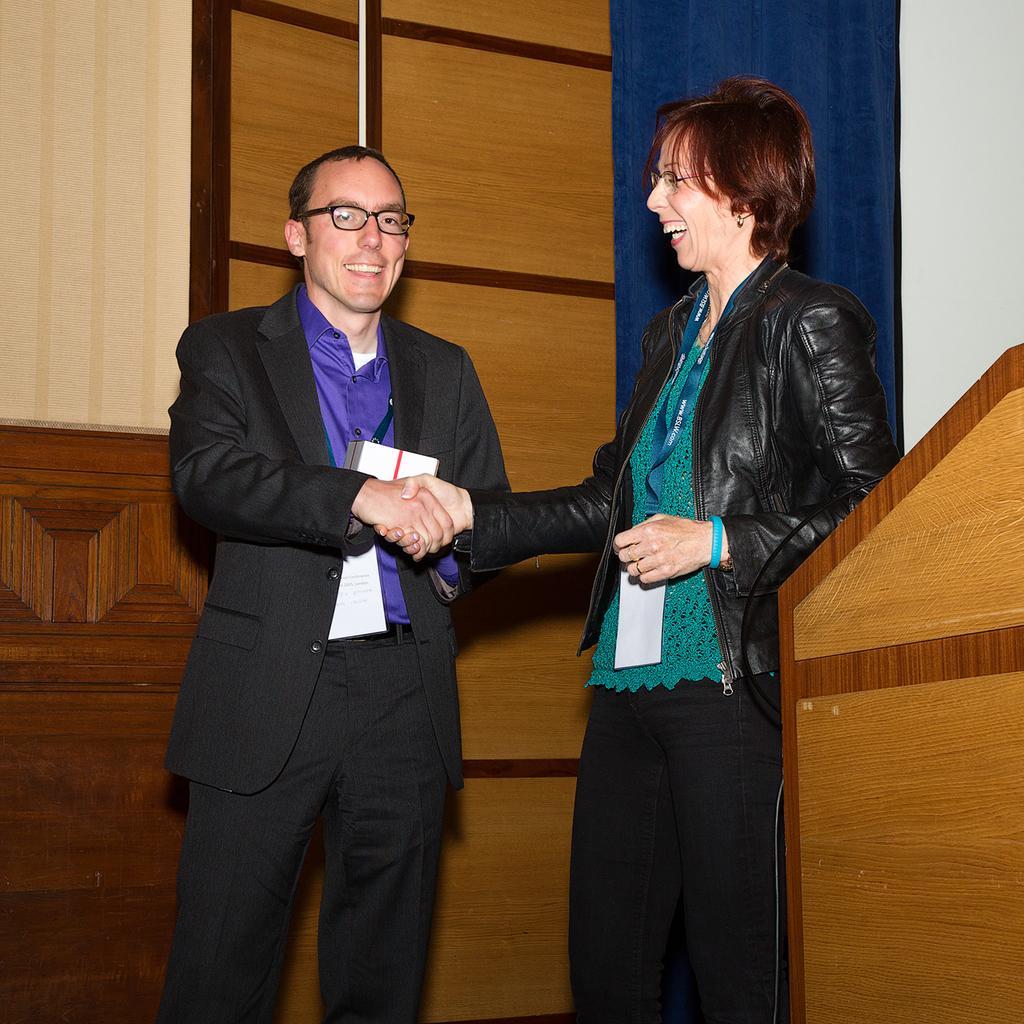How would you summarize this image in a sentence or two? In this image there are two persons standing and smiling by handshaking each other , and there is a podium , wooden wall. 